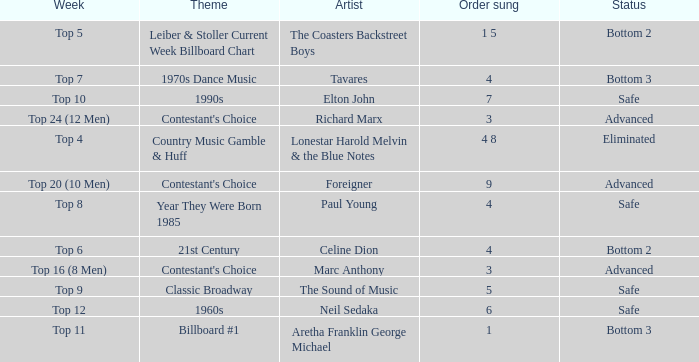What order was the performance of a Richard Marx song? 3.0. 